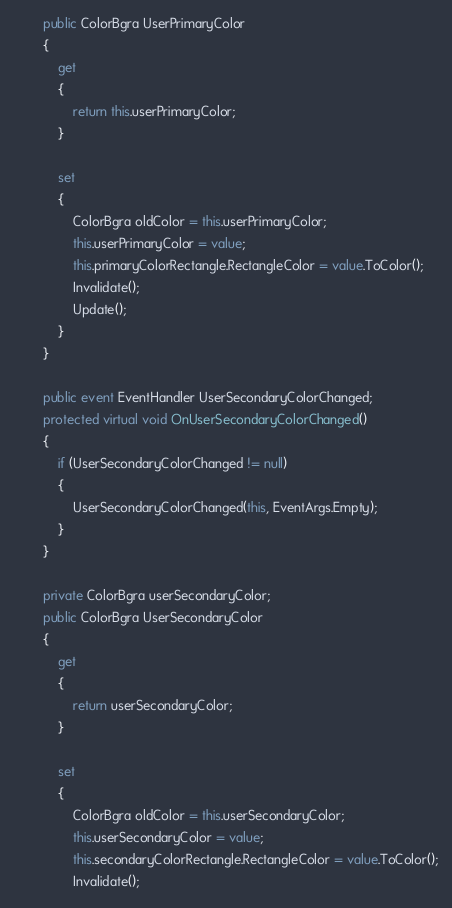Convert code to text. <code><loc_0><loc_0><loc_500><loc_500><_C#_>        public ColorBgra UserPrimaryColor
        {
            get
            {
                return this.userPrimaryColor;
            }

            set
            {
                ColorBgra oldColor = this.userPrimaryColor;
                this.userPrimaryColor = value;
                this.primaryColorRectangle.RectangleColor = value.ToColor();
                Invalidate();
                Update();
            }
        }

        public event EventHandler UserSecondaryColorChanged;
        protected virtual void OnUserSecondaryColorChanged()
        {
            if (UserSecondaryColorChanged != null)
            {
                UserSecondaryColorChanged(this, EventArgs.Empty);
            }
        }

        private ColorBgra userSecondaryColor;
        public ColorBgra UserSecondaryColor
        {
            get
            {
                return userSecondaryColor;
            }

            set
            {
                ColorBgra oldColor = this.userSecondaryColor;
                this.userSecondaryColor = value;
                this.secondaryColorRectangle.RectangleColor = value.ToColor();
                Invalidate();</code> 